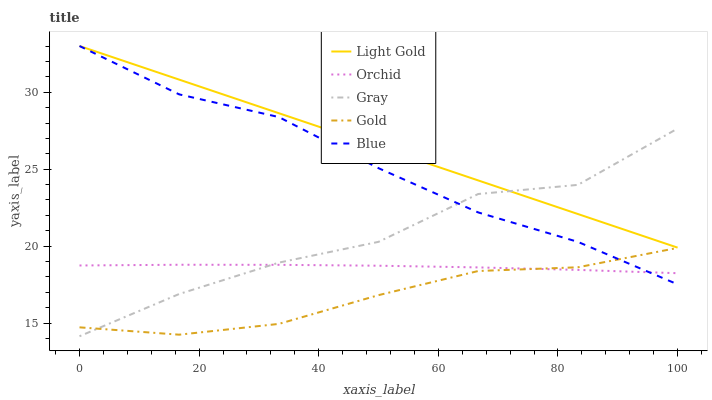Does Gold have the minimum area under the curve?
Answer yes or no. Yes. Does Light Gold have the maximum area under the curve?
Answer yes or no. Yes. Does Gray have the minimum area under the curve?
Answer yes or no. No. Does Gray have the maximum area under the curve?
Answer yes or no. No. Is Light Gold the smoothest?
Answer yes or no. Yes. Is Gray the roughest?
Answer yes or no. Yes. Is Gray the smoothest?
Answer yes or no. No. Is Light Gold the roughest?
Answer yes or no. No. Does Gray have the lowest value?
Answer yes or no. Yes. Does Light Gold have the lowest value?
Answer yes or no. No. Does Light Gold have the highest value?
Answer yes or no. Yes. Does Gray have the highest value?
Answer yes or no. No. Is Orchid less than Light Gold?
Answer yes or no. Yes. Is Light Gold greater than Orchid?
Answer yes or no. Yes. Does Gray intersect Blue?
Answer yes or no. Yes. Is Gray less than Blue?
Answer yes or no. No. Is Gray greater than Blue?
Answer yes or no. No. Does Orchid intersect Light Gold?
Answer yes or no. No. 